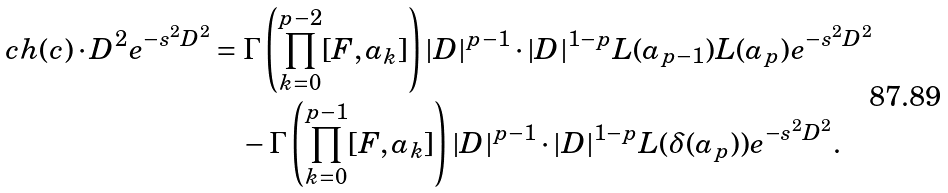<formula> <loc_0><loc_0><loc_500><loc_500>c h ( c ) \cdot D ^ { 2 } e ^ { - s ^ { 2 } D ^ { 2 } } & = \Gamma \left ( \prod _ { k = 0 } ^ { p - 2 } [ F , a _ { k } ] \right ) | D | ^ { p - 1 } \cdot | D | ^ { 1 - p } L ( a _ { p - 1 } ) L ( a _ { p } ) e ^ { - s ^ { 2 } D ^ { 2 } } \\ & \quad - \Gamma \left ( \prod _ { k = 0 } ^ { p - 1 } [ F , a _ { k } ] \right ) | D | ^ { p - 1 } \cdot | D | ^ { 1 - p } L ( \delta ( a _ { p } ) ) e ^ { - s ^ { 2 } D ^ { 2 } } .</formula> 